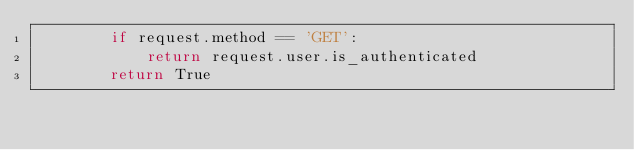Convert code to text. <code><loc_0><loc_0><loc_500><loc_500><_Python_>        if request.method == 'GET':
            return request.user.is_authenticated
        return True
</code> 